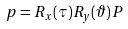<formula> <loc_0><loc_0><loc_500><loc_500>p = R _ { x } ( \tau ) R _ { y } ( \vartheta ) \, P</formula> 